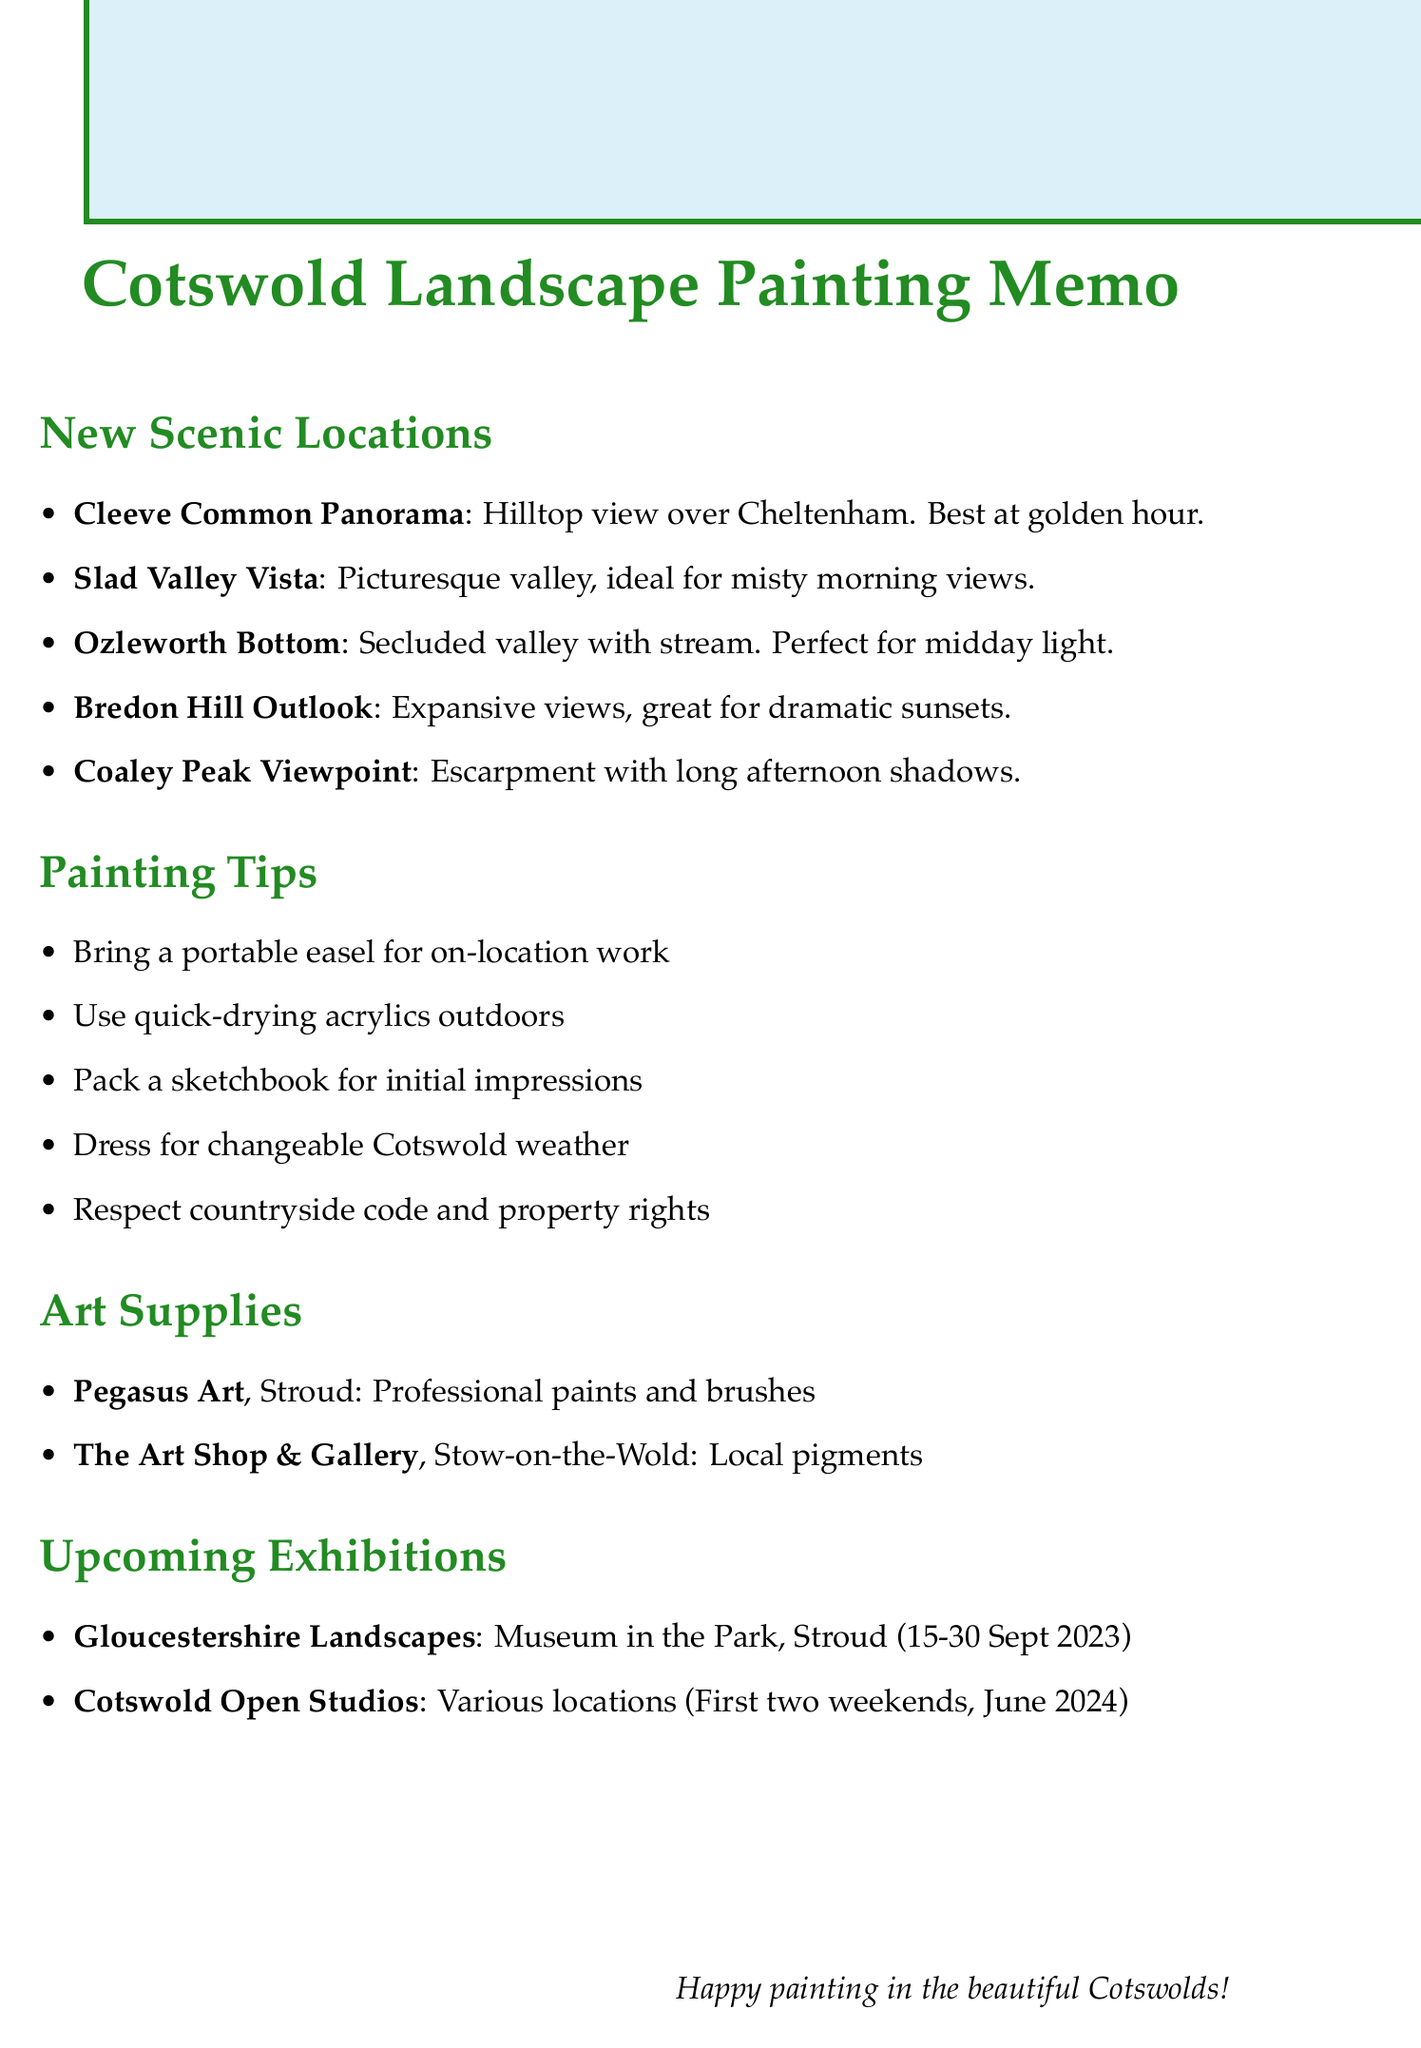What is the name of the location known for its views over Cheltenham? The location noted for its views over Cheltenham is the Cleeve Common Panorama.
Answer: Cleeve Common Panorama When is the best time to paint at Slad Valley Vista? The optimal time for painting at Slad Valley Vista is early morning for misty valley views.
Answer: Early morning What type of art supplies can be found at Pegasus Art? Pegasus Art specializes in a wide range of professional-grade paints and brushes.
Answer: Professional-grade paints and brushes Where is the exhibition "Gloucestershire Landscapes: A Contemporary View" taking place? This exhibition is held at the Museum in the Park, Stroud.
Answer: Museum in the Park, Stroud Which location offers optimal painting conditions at sunset? Bredon Hill Outlook is the location that provides the best conditions for painting at sunset.
Answer: Bredon Hill Outlook What is one of the painting spots at Coaley Peak Viewpoint? One of the painting spots at Coaley Peak Viewpoint is Nympsfield Long Barrow.
Answer: Nympsfield Long Barrow What should you pack for capturing initial impressions when painting outdoors? A small sketchbook should be packed for capturing initial impressions.
Answer: Small sketchbook What specific guidance is given for changeable Cotswold weather? The memo advises wearing appropriate clothing for changeable Cotswold weather.
Answer: Appropriate clothing Which two weekends in June 2024 are for the Cotswold Open Studios? The first two weekends in June 2024 are designated for the Cotswold Open Studios.
Answer: First two weekends in June 2024 